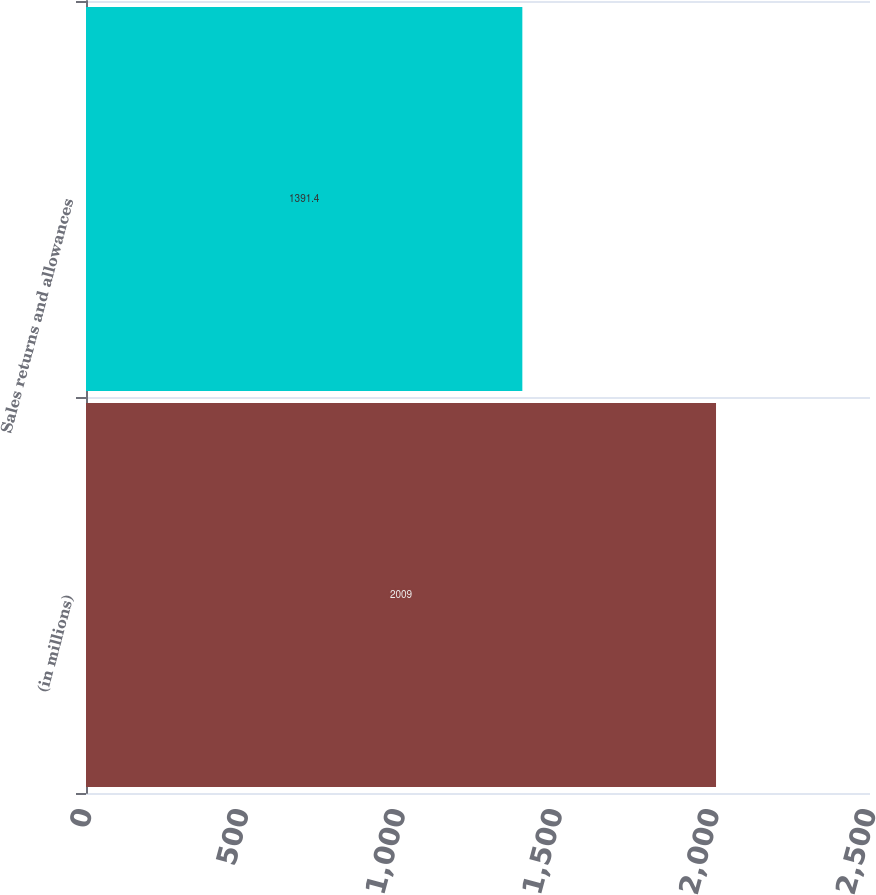Convert chart. <chart><loc_0><loc_0><loc_500><loc_500><bar_chart><fcel>(in millions)<fcel>Sales returns and allowances<nl><fcel>2009<fcel>1391.4<nl></chart> 